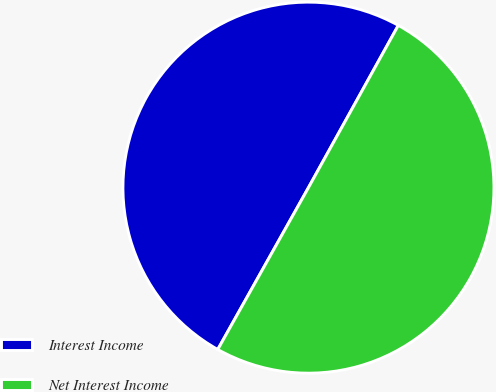Convert chart. <chart><loc_0><loc_0><loc_500><loc_500><pie_chart><fcel>Interest Income<fcel>Net Interest Income<nl><fcel>49.92%<fcel>50.08%<nl></chart> 